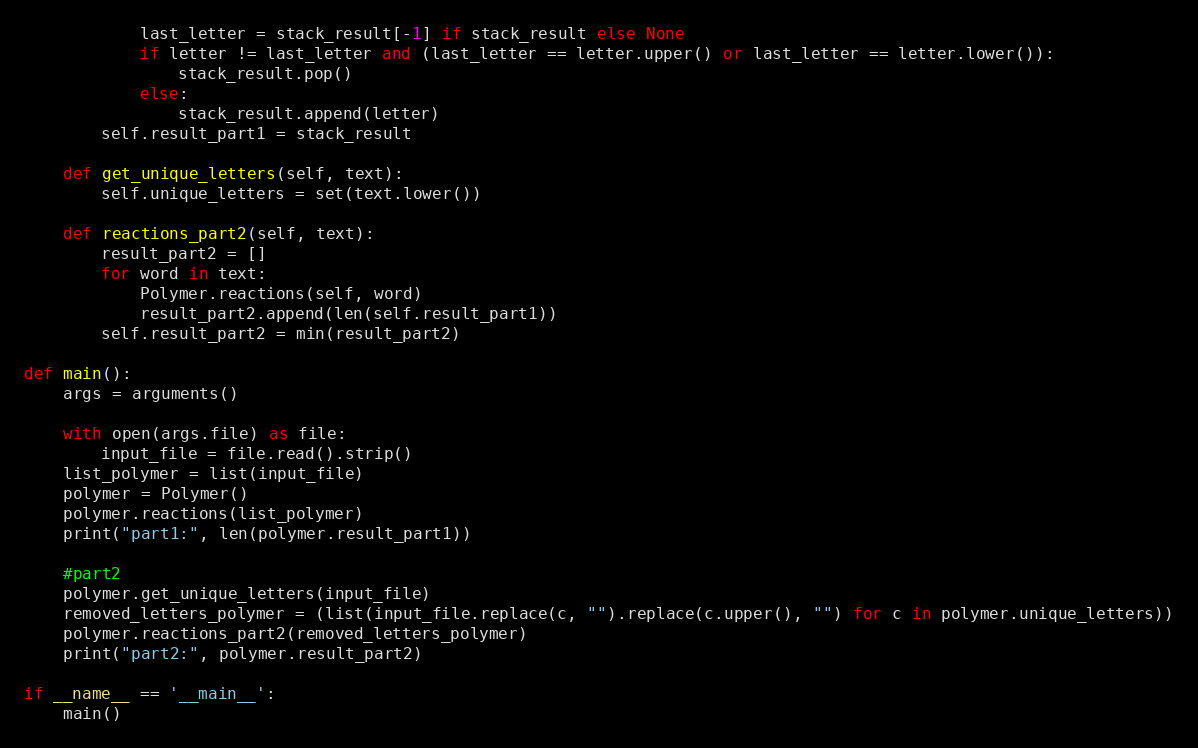<code> <loc_0><loc_0><loc_500><loc_500><_Python_>            last_letter = stack_result[-1] if stack_result else None
            if letter != last_letter and (last_letter == letter.upper() or last_letter == letter.lower()):
                stack_result.pop()
            else:
                stack_result.append(letter)
        self.result_part1 = stack_result

    def get_unique_letters(self, text):
        self.unique_letters = set(text.lower())

    def reactions_part2(self, text):
        result_part2 = []
        for word in text:
            Polymer.reactions(self, word)
            result_part2.append(len(self.result_part1))
        self.result_part2 = min(result_part2)

def main():
    args = arguments()

    with open(args.file) as file:
        input_file = file.read().strip()
    list_polymer = list(input_file)
    polymer = Polymer()
    polymer.reactions(list_polymer)
    print("part1:", len(polymer.result_part1))

    #part2
    polymer.get_unique_letters(input_file)
    removed_letters_polymer = (list(input_file.replace(c, "").replace(c.upper(), "") for c in polymer.unique_letters))
    polymer.reactions_part2(removed_letters_polymer)
    print("part2:", polymer.result_part2)

if __name__ == '__main__':
    main()
</code> 